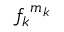<formula> <loc_0><loc_0><loc_500><loc_500>{ f _ { k } } ^ { m _ { k } }</formula> 